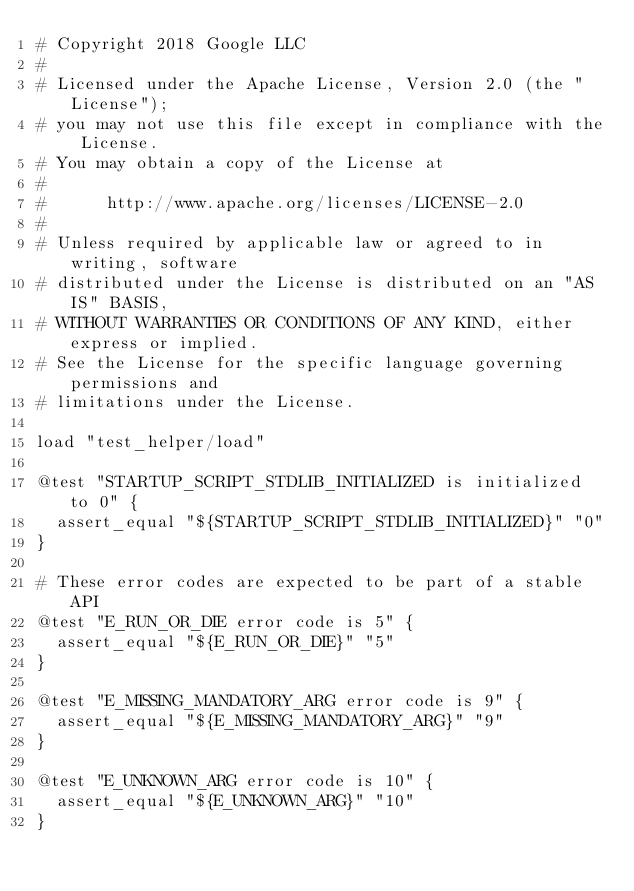Convert code to text. <code><loc_0><loc_0><loc_500><loc_500><_Bash_># Copyright 2018 Google LLC
#
# Licensed under the Apache License, Version 2.0 (the "License");
# you may not use this file except in compliance with the License.
# You may obtain a copy of the License at
#
#      http://www.apache.org/licenses/LICENSE-2.0
#
# Unless required by applicable law or agreed to in writing, software
# distributed under the License is distributed on an "AS IS" BASIS,
# WITHOUT WARRANTIES OR CONDITIONS OF ANY KIND, either express or implied.
# See the License for the specific language governing permissions and
# limitations under the License.

load "test_helper/load"

@test "STARTUP_SCRIPT_STDLIB_INITIALIZED is initialized to 0" {
  assert_equal "${STARTUP_SCRIPT_STDLIB_INITIALIZED}" "0"
}

# These error codes are expected to be part of a stable API
@test "E_RUN_OR_DIE error code is 5" {
  assert_equal "${E_RUN_OR_DIE}" "5"
}

@test "E_MISSING_MANDATORY_ARG error code is 9" {
  assert_equal "${E_MISSING_MANDATORY_ARG}" "9"
}

@test "E_UNKNOWN_ARG error code is 10" {
  assert_equal "${E_UNKNOWN_ARG}" "10"
}
</code> 